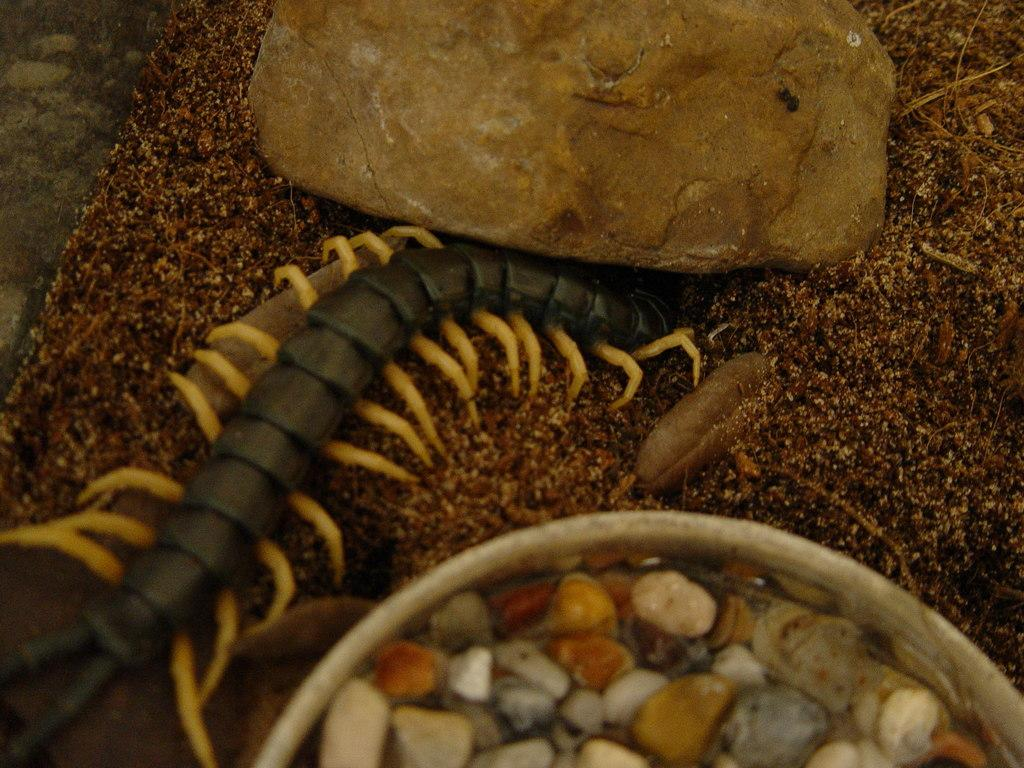What type of creature is in the image? There is an insect in the image. What is the color scheme of the background in the image? The insect is on a black and white background. What can be seen at the bottom of the image? There are stones in a bucket at the bottom of the image. What type of terrain is visible in the image? There is sand in the image, and there is also a big rock. Can you tell me how many goats are grazing near the big rock in the image? There are no goats present in the image; it features an insect on a black and white background, stones in a bucket, sand, and a big rock. What type of boundary can be seen between the sand and the big rock in the image? There is no boundary visible between the sand and the big rock in the image. 